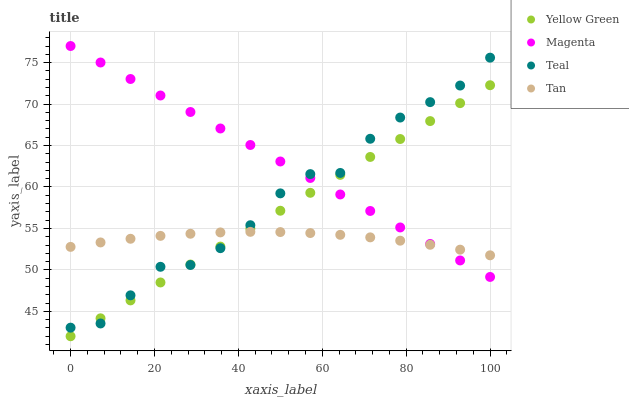Does Tan have the minimum area under the curve?
Answer yes or no. Yes. Does Magenta have the maximum area under the curve?
Answer yes or no. Yes. Does Yellow Green have the minimum area under the curve?
Answer yes or no. No. Does Yellow Green have the maximum area under the curve?
Answer yes or no. No. Is Yellow Green the smoothest?
Answer yes or no. Yes. Is Teal the roughest?
Answer yes or no. Yes. Is Tan the smoothest?
Answer yes or no. No. Is Tan the roughest?
Answer yes or no. No. Does Yellow Green have the lowest value?
Answer yes or no. Yes. Does Tan have the lowest value?
Answer yes or no. No. Does Magenta have the highest value?
Answer yes or no. Yes. Does Yellow Green have the highest value?
Answer yes or no. No. Does Yellow Green intersect Tan?
Answer yes or no. Yes. Is Yellow Green less than Tan?
Answer yes or no. No. Is Yellow Green greater than Tan?
Answer yes or no. No. 